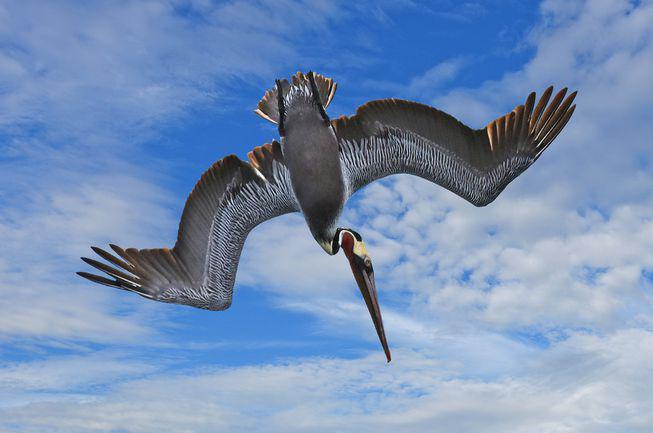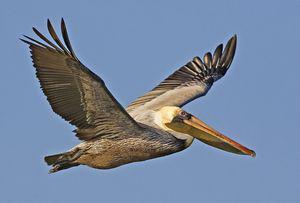The first image is the image on the left, the second image is the image on the right. Given the left and right images, does the statement "The birds in both images are diving into the water with their heads facing right." hold true? Answer yes or no. No. The first image is the image on the left, the second image is the image on the right. Analyze the images presented: Is the assertion "Both images show diving pelicans, and the birds in the left and right images have their heads facing toward each other." valid? Answer yes or no. No. 